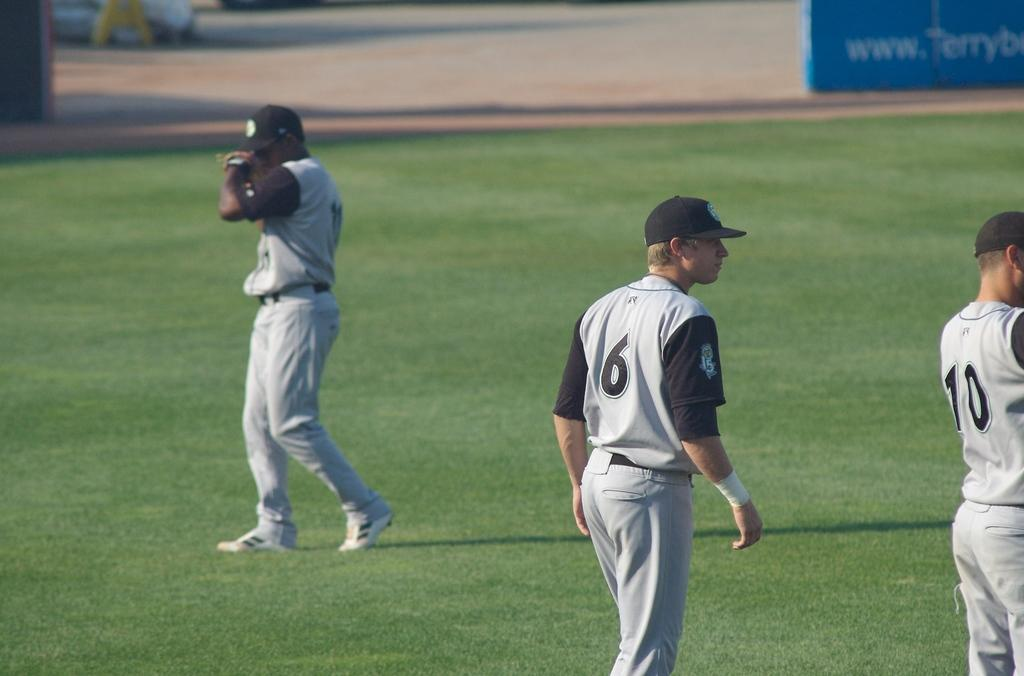<image>
Summarize the visual content of the image. Three basbeball players stand on the field of player, number 6 and 10 are closest. 